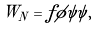<formula> <loc_0><loc_0><loc_500><loc_500>W _ { N } = f \phi \psi \psi ,</formula> 